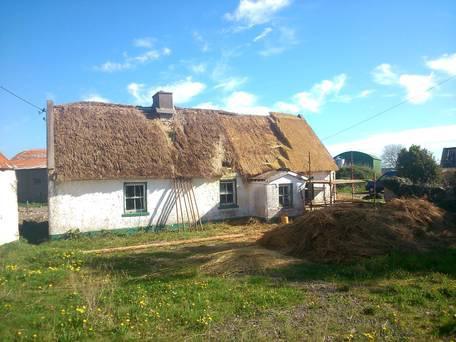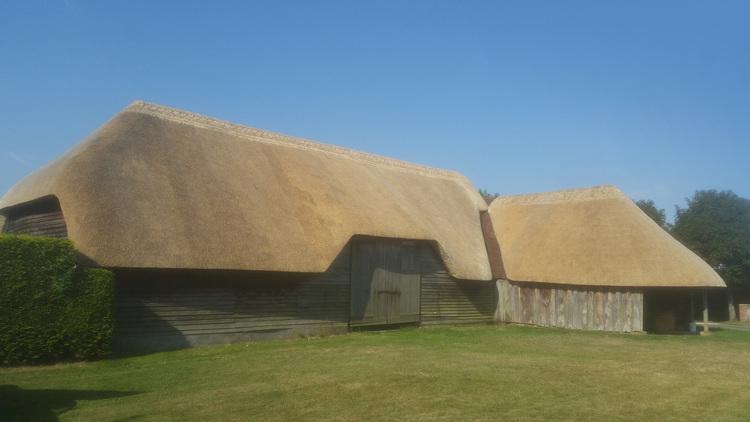The first image is the image on the left, the second image is the image on the right. Evaluate the accuracy of this statement regarding the images: "In one image, thatch is piled in a heap in front of a non-brick buildling being re-thatched, with new thatch on the right side of the roof.". Is it true? Answer yes or no. Yes. The first image is the image on the left, the second image is the image on the right. For the images displayed, is the sentence "In the left image, the roof is currently being thatched; the thatching has started, but has not completed." factually correct? Answer yes or no. Yes. 